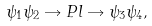<formula> <loc_0><loc_0><loc_500><loc_500>\psi _ { 1 } \psi _ { 2 } \rightarrow P l \rightarrow \psi _ { 3 } \psi _ { 4 } ,</formula> 